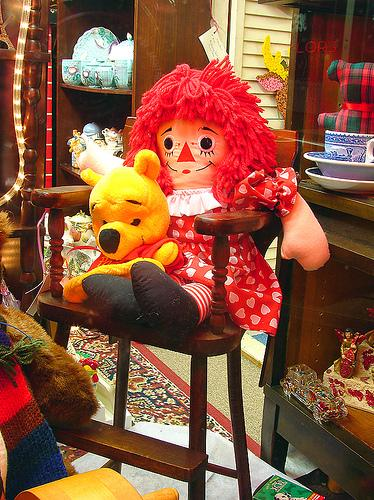What iconic child favorite is there besides Winnie the Pooh? raggedy ann 